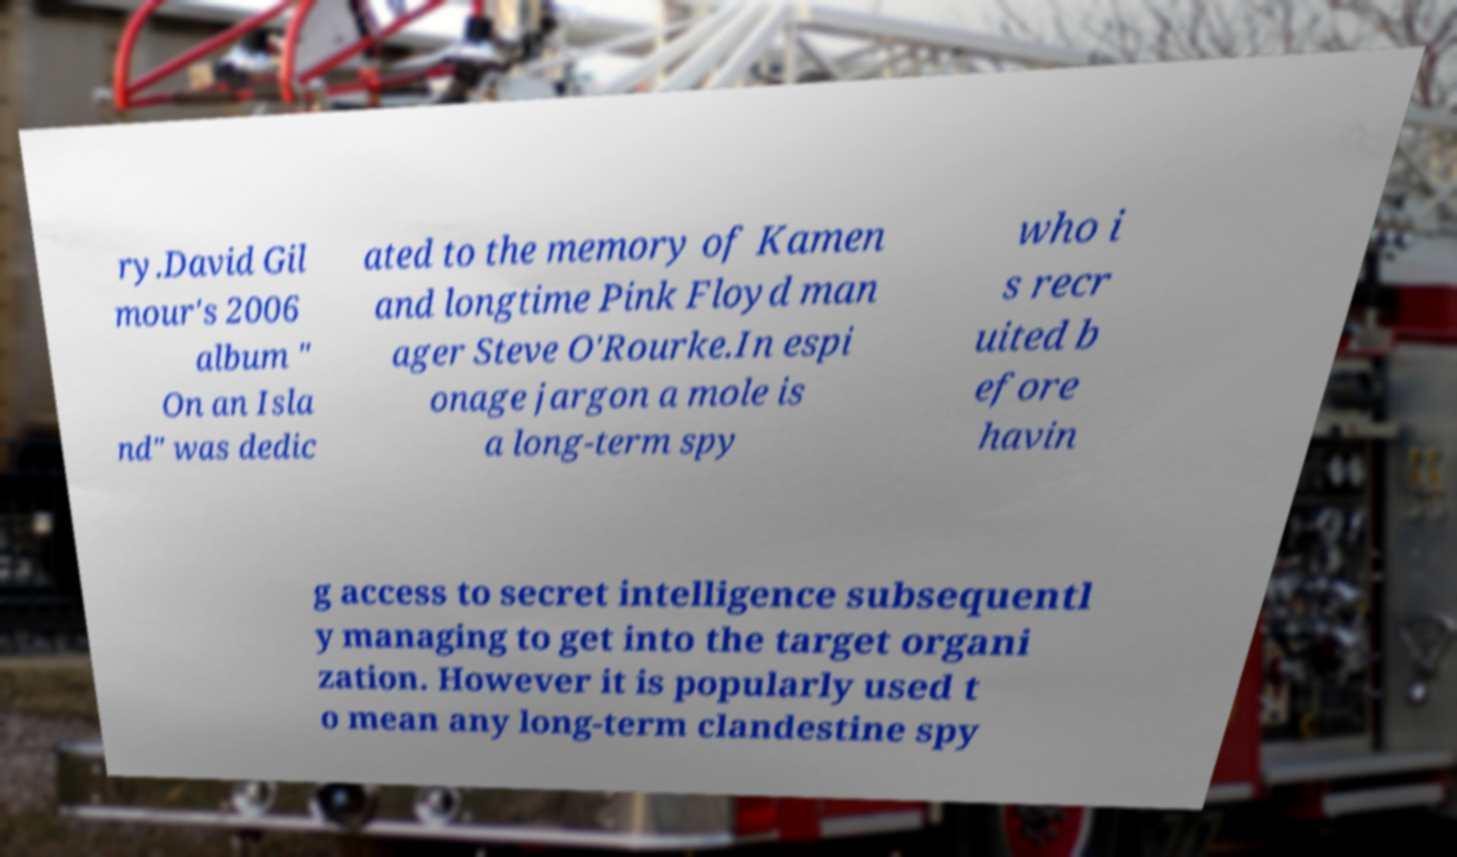For documentation purposes, I need the text within this image transcribed. Could you provide that? ry.David Gil mour's 2006 album " On an Isla nd" was dedic ated to the memory of Kamen and longtime Pink Floyd man ager Steve O'Rourke.In espi onage jargon a mole is a long-term spy who i s recr uited b efore havin g access to secret intelligence subsequentl y managing to get into the target organi zation. However it is popularly used t o mean any long-term clandestine spy 